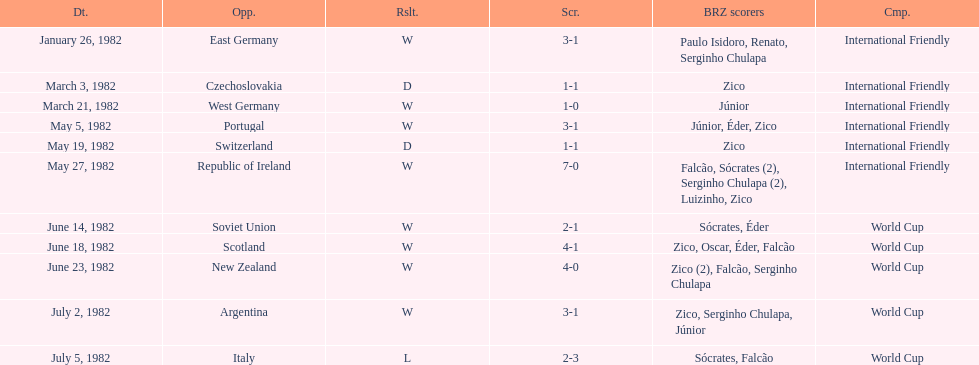Can you give me this table as a dict? {'header': ['Dt.', 'Opp.', 'Rslt.', 'Scr.', 'BRZ scorers', 'Cmp.'], 'rows': [['January 26, 1982', 'East Germany', 'W', '3-1', 'Paulo Isidoro, Renato, Serginho Chulapa', 'International Friendly'], ['March 3, 1982', 'Czechoslovakia', 'D', '1-1', 'Zico', 'International Friendly'], ['March 21, 1982', 'West Germany', 'W', '1-0', 'Júnior', 'International Friendly'], ['May 5, 1982', 'Portugal', 'W', '3-1', 'Júnior, Éder, Zico', 'International Friendly'], ['May 19, 1982', 'Switzerland', 'D', '1-1', 'Zico', 'International Friendly'], ['May 27, 1982', 'Republic of Ireland', 'W', '7-0', 'Falcão, Sócrates (2), Serginho Chulapa (2), Luizinho, Zico', 'International Friendly'], ['June 14, 1982', 'Soviet Union', 'W', '2-1', 'Sócrates, Éder', 'World Cup'], ['June 18, 1982', 'Scotland', 'W', '4-1', 'Zico, Oscar, Éder, Falcão', 'World Cup'], ['June 23, 1982', 'New Zealand', 'W', '4-0', 'Zico (2), Falcão, Serginho Chulapa', 'World Cup'], ['July 2, 1982', 'Argentina', 'W', '3-1', 'Zico, Serginho Chulapa, Júnior', 'World Cup'], ['July 5, 1982', 'Italy', 'L', '2-3', 'Sócrates, Falcão', 'World Cup']]} Who was this team's next opponent after facing the soviet union on june 14? Scotland. 